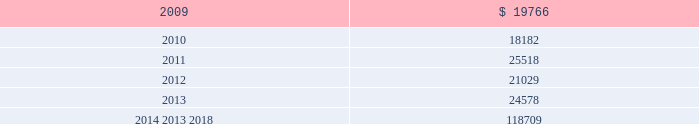Mastercard incorporated notes to consolidated financial statements 2014 ( continued ) ( in thousands , except percent and per share data ) the table summarizes expected benefit payments through 2018 including those payments expected to be paid from the company 2019s general assets .
Since the majority of the benefit payments are made in the form of lump-sum distributions , actual benefit payments may differ from expected benefits payments. .
Substantially all of the company 2019s u.s .
Employees are eligible to participate in a defined contribution savings plan ( the 201csavings plan 201d ) sponsored by the company .
The savings plan allows employees to contribute a portion of their base compensation on a pre-tax and after-tax basis in accordance with specified guidelines .
The company matches a percentage of employees 2019 contributions up to certain limits .
In 2007 and prior years , the company could also contribute to the savings plan a discretionary profit sharing component linked to company performance during the prior year .
Beginning in 2008 , the discretionary profit sharing amount related to 2007 company performance was paid directly to employees as a short-term cash incentive bonus rather than as a contribution to the savings plan .
In addition , the company has several defined contribution plans outside of the united states .
The company 2019s contribution expense related to all of its defined contribution plans was $ 35341 , $ 26996 and $ 43594 for 2008 , 2007 and 2006 , respectively .
The company had a value appreciation program ( 201cvap 201d ) , which was an incentive compensation plan established in 1995 .
Annual awards were granted to vap participants from 1995 through 1998 , which entitled participants to the net appreciation on a portfolio of securities of members of mastercard international .
In 1999 , the vap was replaced by an executive incentive plan ( 201ceip 201d ) and the senior executive incentive plan ( 201cseip 201d ) ( together the 201ceip plans 201d ) ( see note 16 ( share based payments and other benefits ) ) .
Contributions to the vap have been discontinued , all plan assets have been disbursed and no vap liability remained as of december 31 , 2008 .
The company 2019s liability related to the vap at december 31 , 2007 was $ 986 .
The expense ( benefit ) was $ ( 6 ) , $ ( 267 ) and $ 3406 for the years ended december 31 , 2008 , 2007 and 2006 , respectively .
Note 12 .
Postemployment and postretirement benefits the company maintains a postretirement plan ( the 201cpostretirement plan 201d ) providing health coverage and life insurance benefits for substantially all of its u.s .
Employees and retirees hired before july 1 , 2007 .
The company amended the life insurance benefits under the postretirement plan effective january 1 , 2007 .
The impact , net of taxes , of this amendment was an increase of $ 1715 to accumulated other comprehensive income in 2007. .
What is the variation observed in the expected benefits payment in 2009 and 2010? 
Rationale: it is the difference between the expected benefits payments for both years .
Computations: (19766 - 18182)
Answer: 1584.0. 